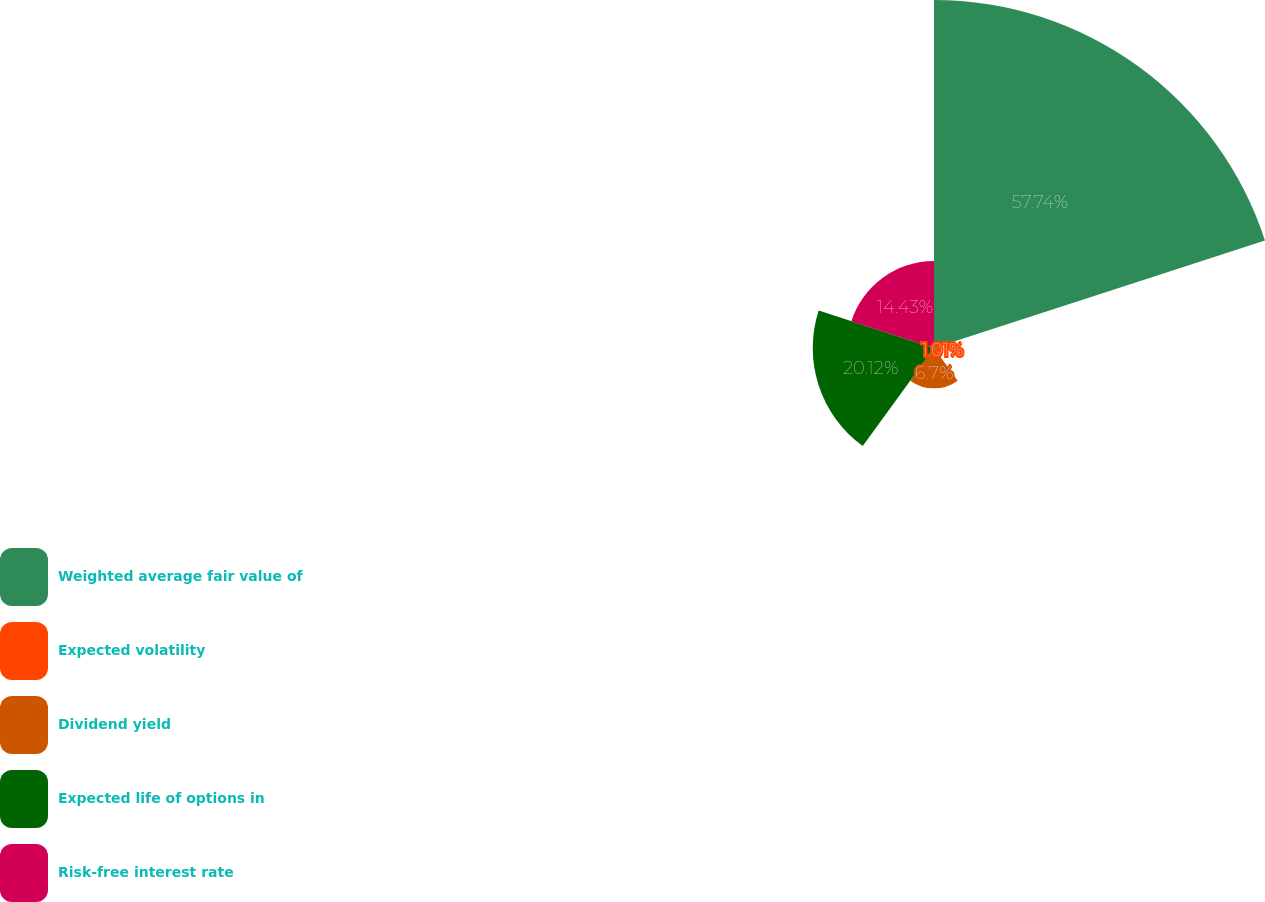Convert chart. <chart><loc_0><loc_0><loc_500><loc_500><pie_chart><fcel>Weighted average fair value of<fcel>Expected volatility<fcel>Dividend yield<fcel>Expected life of options in<fcel>Risk-free interest rate<nl><fcel>57.75%<fcel>1.01%<fcel>6.7%<fcel>20.12%<fcel>14.43%<nl></chart> 